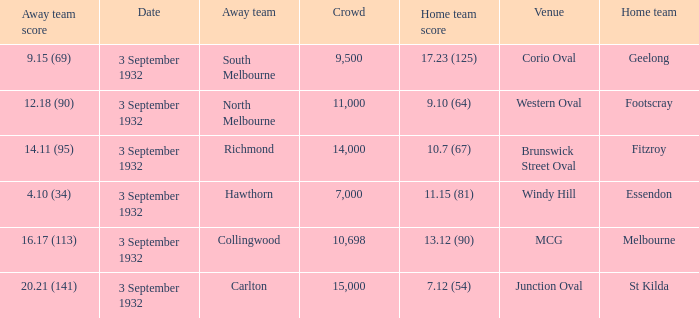What date is listed for the team that has an Away team score of 20.21 (141)? 3 September 1932. 